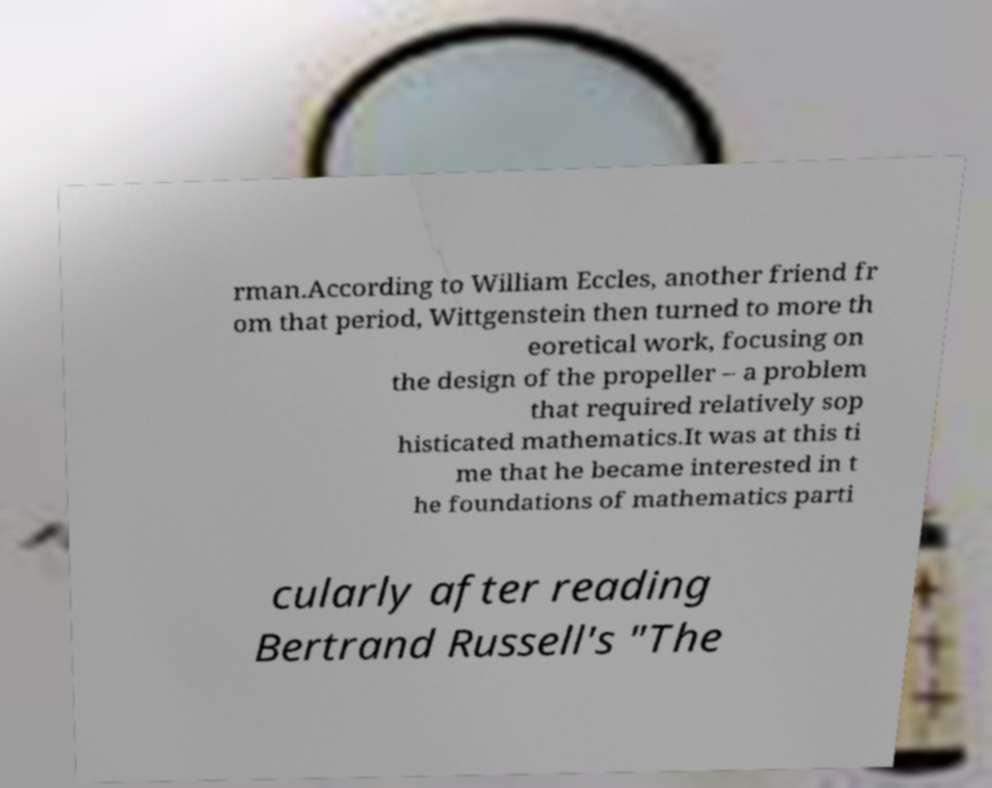Could you assist in decoding the text presented in this image and type it out clearly? rman.According to William Eccles, another friend fr om that period, Wittgenstein then turned to more th eoretical work, focusing on the design of the propeller – a problem that required relatively sop histicated mathematics.It was at this ti me that he became interested in t he foundations of mathematics parti cularly after reading Bertrand Russell's "The 